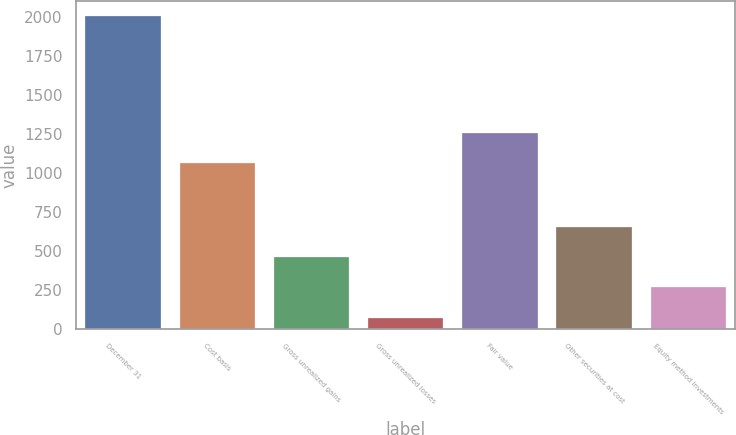Convert chart to OTSL. <chart><loc_0><loc_0><loc_500><loc_500><bar_chart><fcel>December 31<fcel>Cost basis<fcel>Gross unrealized gains<fcel>Gross unrealized losses<fcel>Fair value<fcel>Other securities at cost<fcel>Equity method investments<nl><fcel>2005<fcel>1065<fcel>461<fcel>75<fcel>1258<fcel>654<fcel>268<nl></chart> 